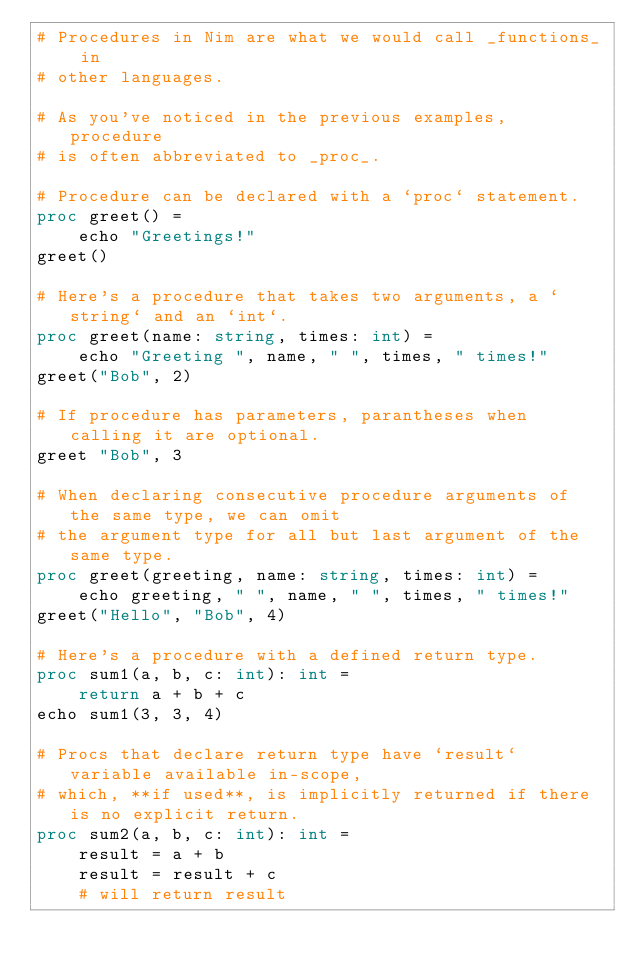<code> <loc_0><loc_0><loc_500><loc_500><_Nim_># Procedures in Nim are what we would call _functions_ in
# other languages.

# As you've noticed in the previous examples, procedure
# is often abbreviated to _proc_.

# Procedure can be declared with a `proc` statement.
proc greet() =
    echo "Greetings!"
greet()

# Here's a procedure that takes two arguments, a `string` and an `int`.
proc greet(name: string, times: int) =
    echo "Greeting ", name, " ", times, " times!"
greet("Bob", 2)

# If procedure has parameters, parantheses when calling it are optional.
greet "Bob", 3

# When declaring consecutive procedure arguments of the same type, we can omit
# the argument type for all but last argument of the same type.
proc greet(greeting, name: string, times: int) =
    echo greeting, " ", name, " ", times, " times!"
greet("Hello", "Bob", 4)

# Here's a procedure with a defined return type.
proc sum1(a, b, c: int): int =
    return a + b + c
echo sum1(3, 3, 4)

# Procs that declare return type have `result` variable available in-scope,
# which, **if used**, is implicitly returned if there is no explicit return.
proc sum2(a, b, c: int): int =
    result = a + b
    result = result + c
    # will return result</code> 